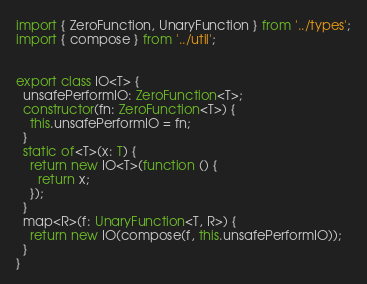Convert code to text. <code><loc_0><loc_0><loc_500><loc_500><_TypeScript_>import { ZeroFunction, UnaryFunction } from '../types';
import { compose } from '../util';


export class IO<T> {
  unsafePerformIO: ZeroFunction<T>;
  constructor(fn: ZeroFunction<T>) {
    this.unsafePerformIO = fn;
  }
  static of<T>(x: T) {
    return new IO<T>(function () {
      return x;
    });
  }
  map<R>(f: UnaryFunction<T, R>) {
    return new IO(compose(f, this.unsafePerformIO));
  }
}
</code> 